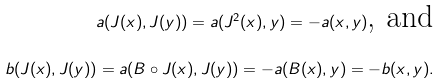<formula> <loc_0><loc_0><loc_500><loc_500>a ( J ( x ) , J ( y ) ) = a ( J ^ { 2 } ( x ) , y ) = - a ( x , y ) \text {, and} \\ b ( J ( x ) , J ( y ) ) = a ( B \circ J ( x ) , J ( y ) ) = - a ( B ( x ) , y ) = - b ( x , y ) .</formula> 